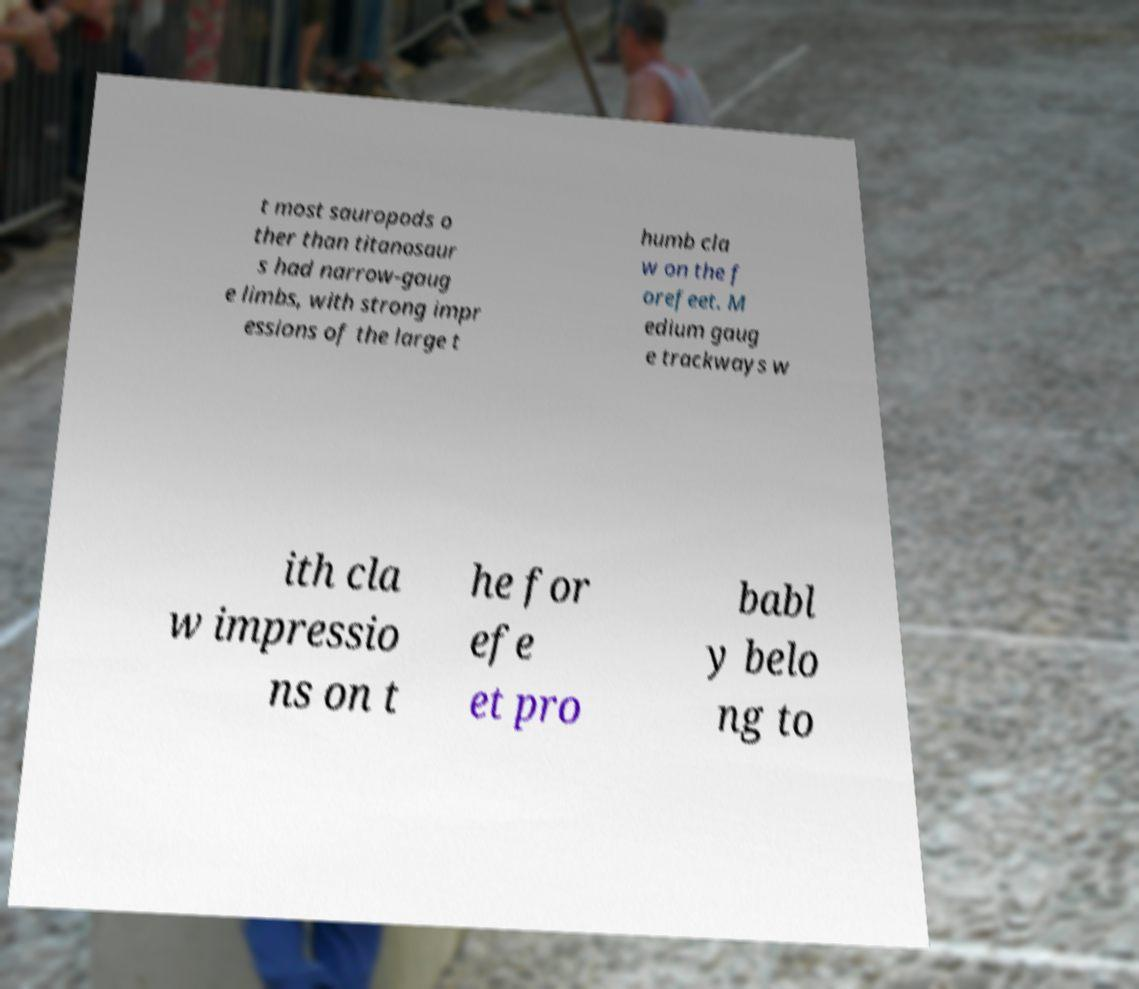Please read and relay the text visible in this image. What does it say? t most sauropods o ther than titanosaur s had narrow-gaug e limbs, with strong impr essions of the large t humb cla w on the f orefeet. M edium gaug e trackways w ith cla w impressio ns on t he for efe et pro babl y belo ng to 